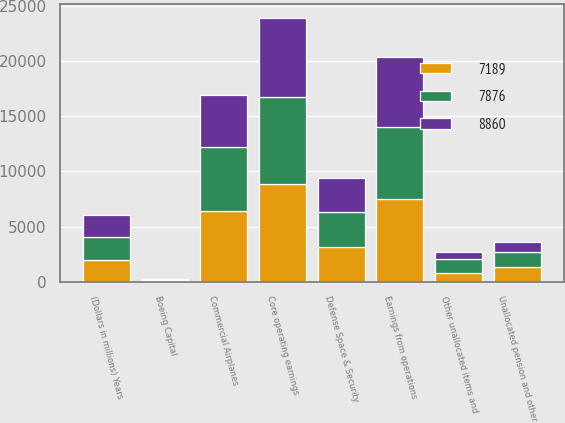Convert chart to OTSL. <chart><loc_0><loc_0><loc_500><loc_500><stacked_bar_chart><ecel><fcel>(Dollars in millions) Years<fcel>Commercial Airplanes<fcel>Defense Space & Security<fcel>Boeing Capital<fcel>Unallocated pension and other<fcel>Other unallocated items and<fcel>Earnings from operations<fcel>Core operating earnings<nl><fcel>7189<fcel>2014<fcel>6411<fcel>3133<fcel>92<fcel>1387<fcel>776<fcel>7473<fcel>8860<nl><fcel>7876<fcel>2013<fcel>5795<fcel>3235<fcel>107<fcel>1314<fcel>1261<fcel>6562<fcel>7876<nl><fcel>8860<fcel>2012<fcel>4711<fcel>3068<fcel>88<fcel>899<fcel>678<fcel>6290<fcel>7189<nl></chart> 